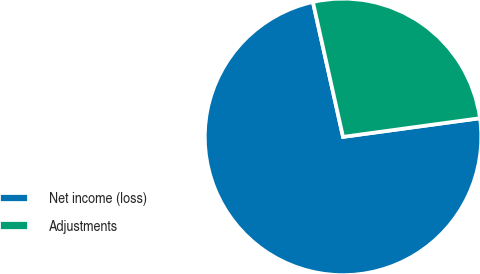Convert chart to OTSL. <chart><loc_0><loc_0><loc_500><loc_500><pie_chart><fcel>Net income (loss)<fcel>Adjustments<nl><fcel>73.66%<fcel>26.34%<nl></chart> 